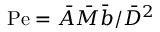<formula> <loc_0><loc_0><loc_500><loc_500>P e = \bar { A } \bar { M } \bar { b } / \bar { D } ^ { 2 }</formula> 